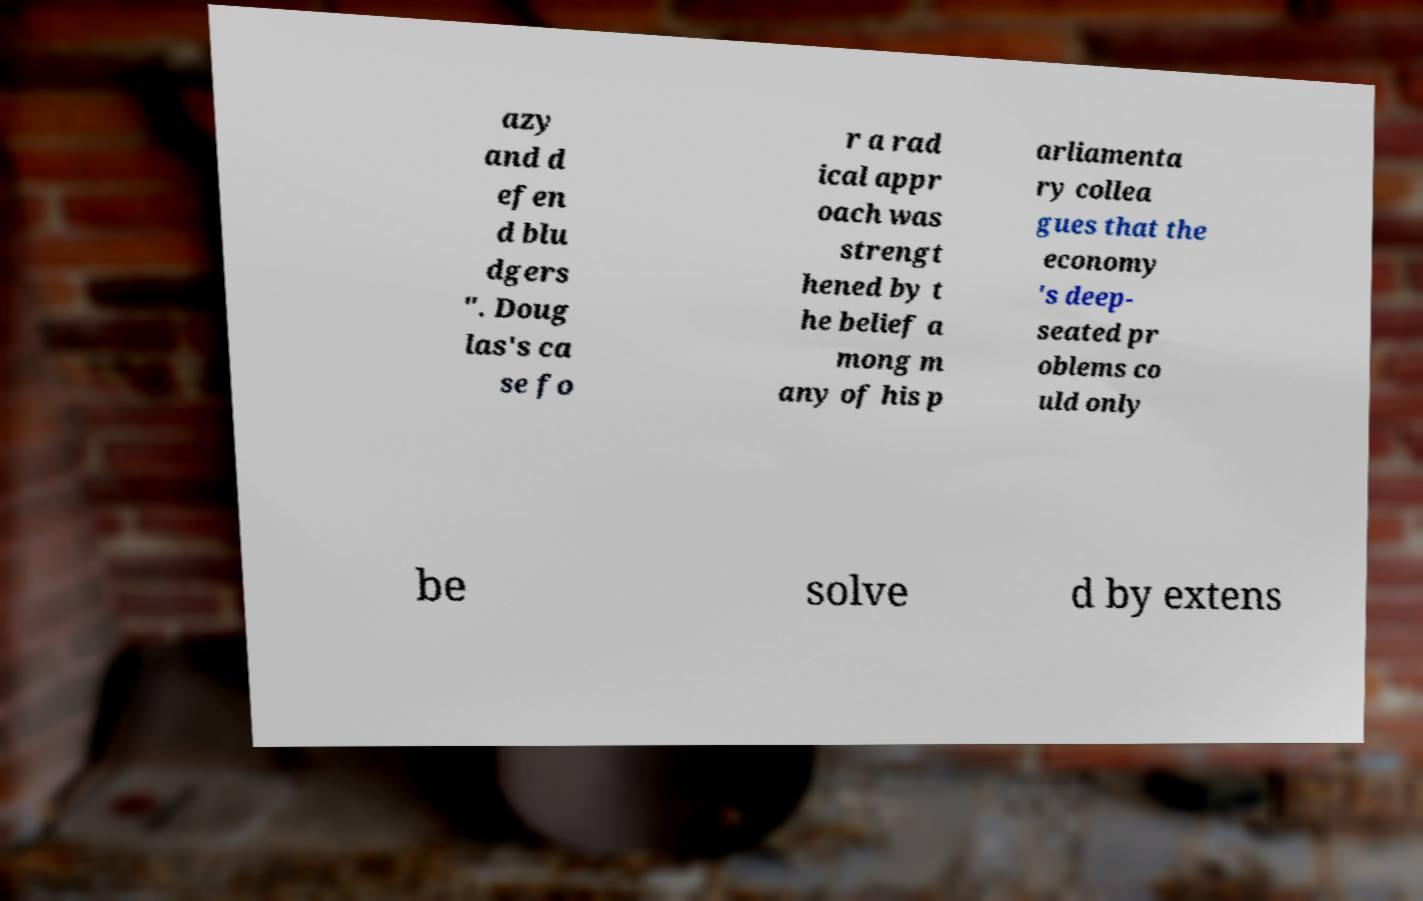Could you extract and type out the text from this image? azy and d efen d blu dgers ". Doug las's ca se fo r a rad ical appr oach was strengt hened by t he belief a mong m any of his p arliamenta ry collea gues that the economy 's deep- seated pr oblems co uld only be solve d by extens 